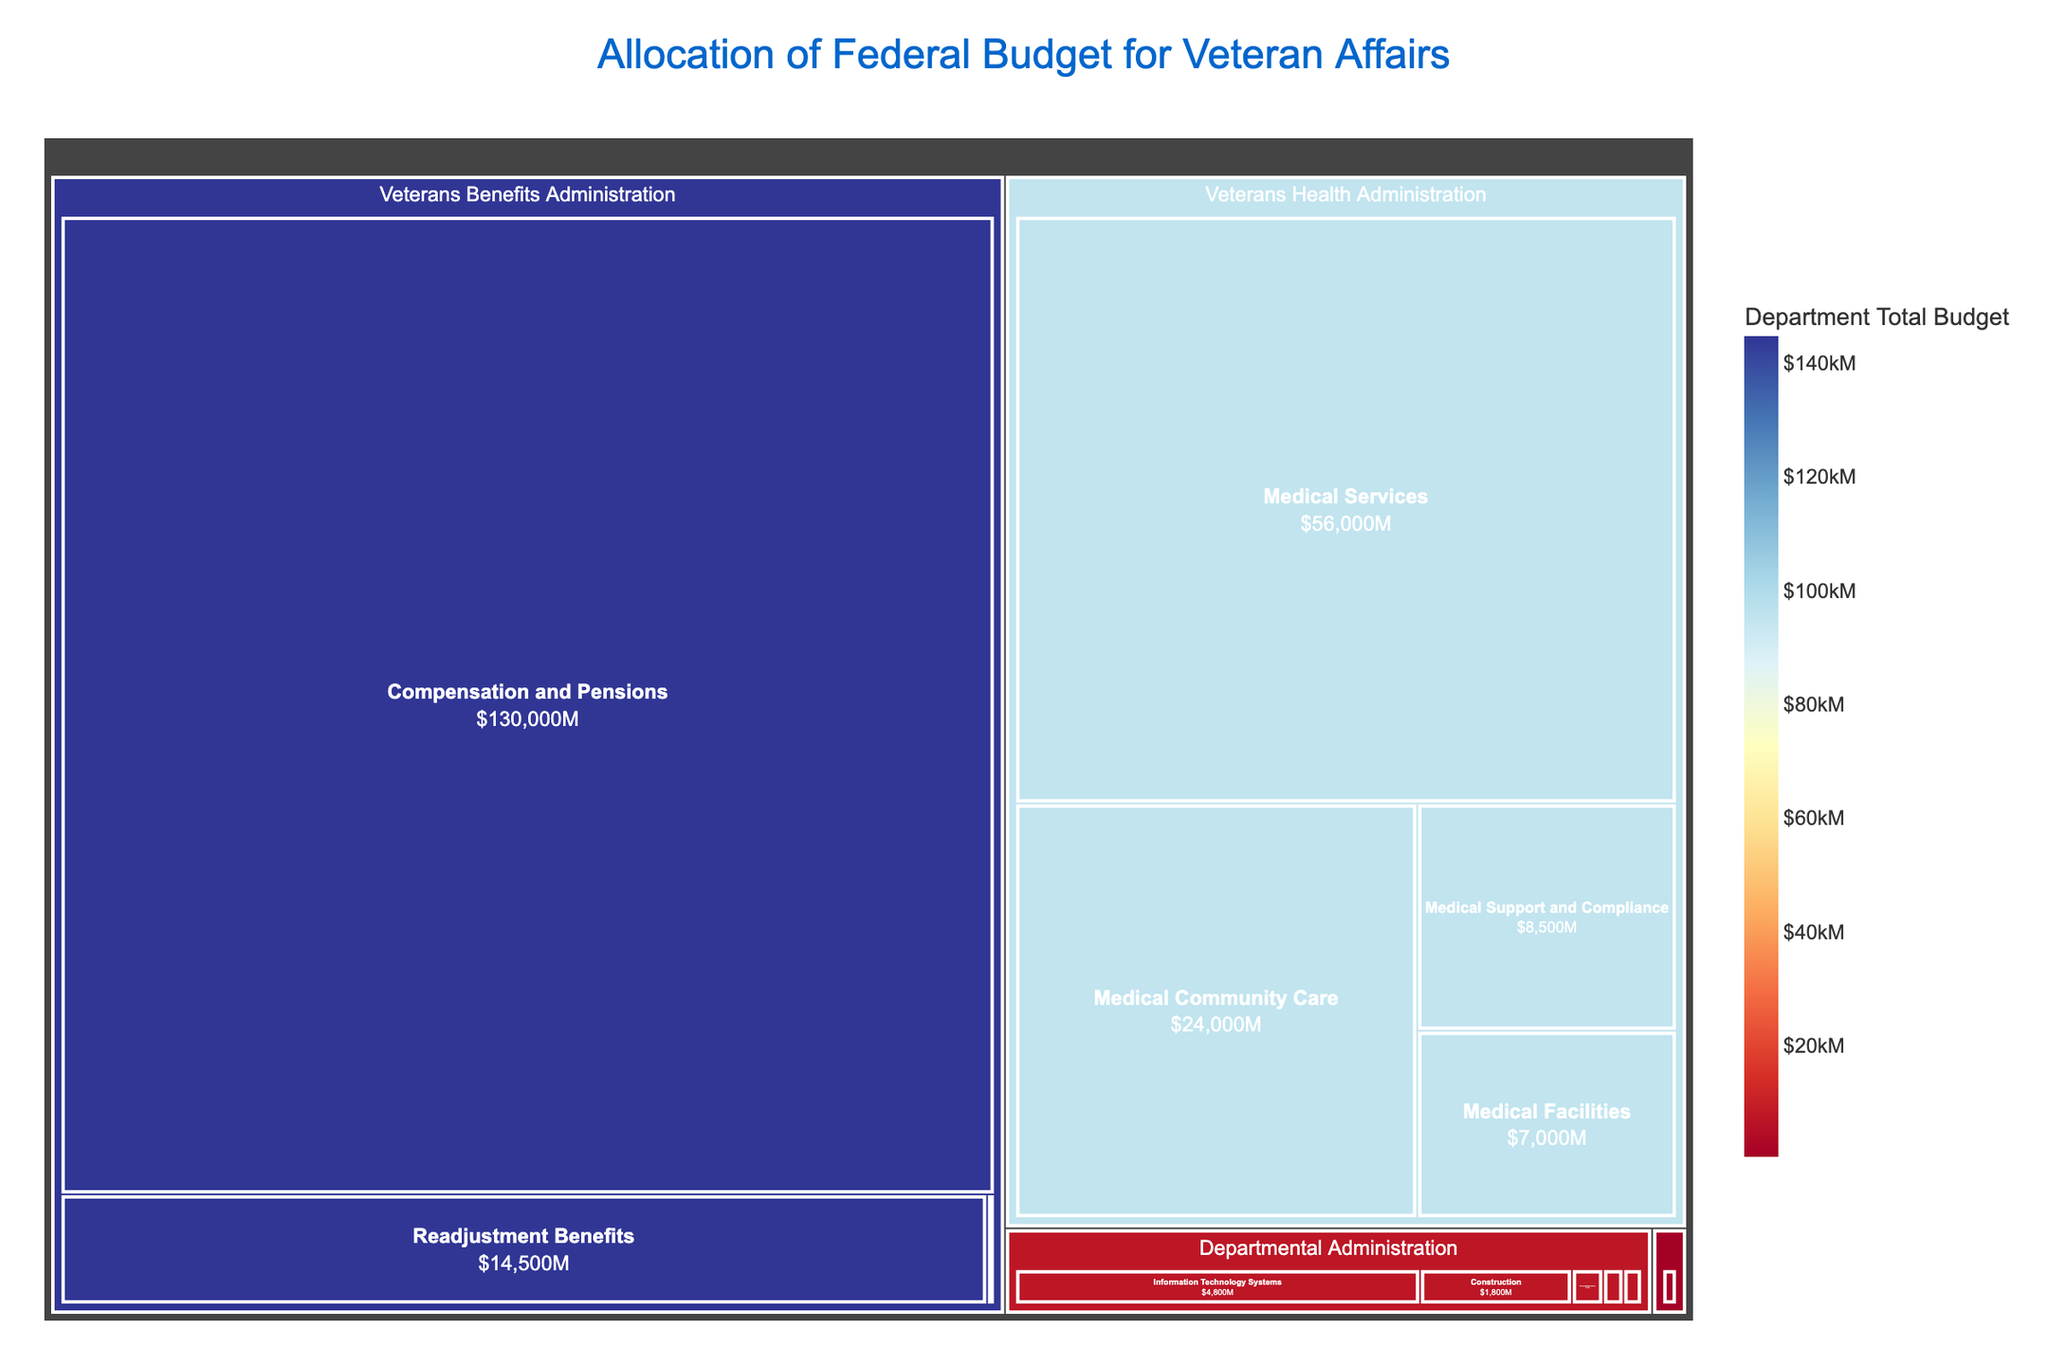How much budget is allocated to the Medical Services program? The Medical Services program belongs to the Veterans Health Administration. The corresponding budget amount can be read directly from the figure.
Answer: $56,000M Which department has the highest total budget? To find the department with the highest total budget, look for the largest section in the figure which represents that department. The largest section corresponds to the Veterans Benefits Administration.
Answer: Veterans Benefits Administration What is the combined budget for the Medical Community Care and Medical Facilities programs? To find the combined budget, locate the budget amounts for Medical Community Care ($24,000M) and Medical Facilities ($7,000M) and sum them up.
Answer: $31,000M Compare the budget of Veterans Health Administration's Medical Support and Compliance program to that of the Departmental Administration's Information Technology Systems program. First, locate the budgets for both programs: Medical Support and Compliance is $8,500M and Information Technology Systems is $4,800M. The Medical Support and Compliance program has a higher budget.
Answer: Medical Support and Compliance has a higher budget Which program under the Departmental Administration has the smallest budget? The smallest budget within the Departmental Administration can be found by identifying the smallest segment within its area. The General Administration program has the smallest budget of $370M.
Answer: General Administration What is the total budget allocated to the Veterans Health Administration? The total budget for the Veterans Health Administration is calculated by summing the budgets of its programs: Medical Services ($56,000M) + Medical Community Care ($24,000M) + Medical Support and Compliance ($8,500M) + Medical Facilities ($7,000M).
Answer: $95,500M How does the budget of the Readjustment Benefits program compare to that of the Compensation and Pensions program? The budget of Readjustment Benefits ($14,500M) can be compared directly to Compensation and Pensions ($130,000M). The Compensation and Pensions program has a significantly higher budget.
Answer: Compensation and Pensions has a significantly higher budget Which department's total budget is shown using the strongest color intensity in the treemap? The strongest color intensity in the treemap highlights the department with the highest total budget. The Veterans Benefits Administration is shown with the strongest color intensity.
Answer: Veterans Benefits Administration How much more budget is allocated to Compensation and Pensions than to the Insurance and Indemnities program? The key budgets are Compensation and Pensions ($130,000M) and Insurance and Indemnities ($120M). Subtract the smaller from the larger to find the difference. ($130,000M - $120M).
Answer: $129,880M What is the budget for the Office of Inspector General program? The Office of Inspector General is a program under Departmental Administration. Its budget is displayed directly in the treemap.
Answer: $240M 